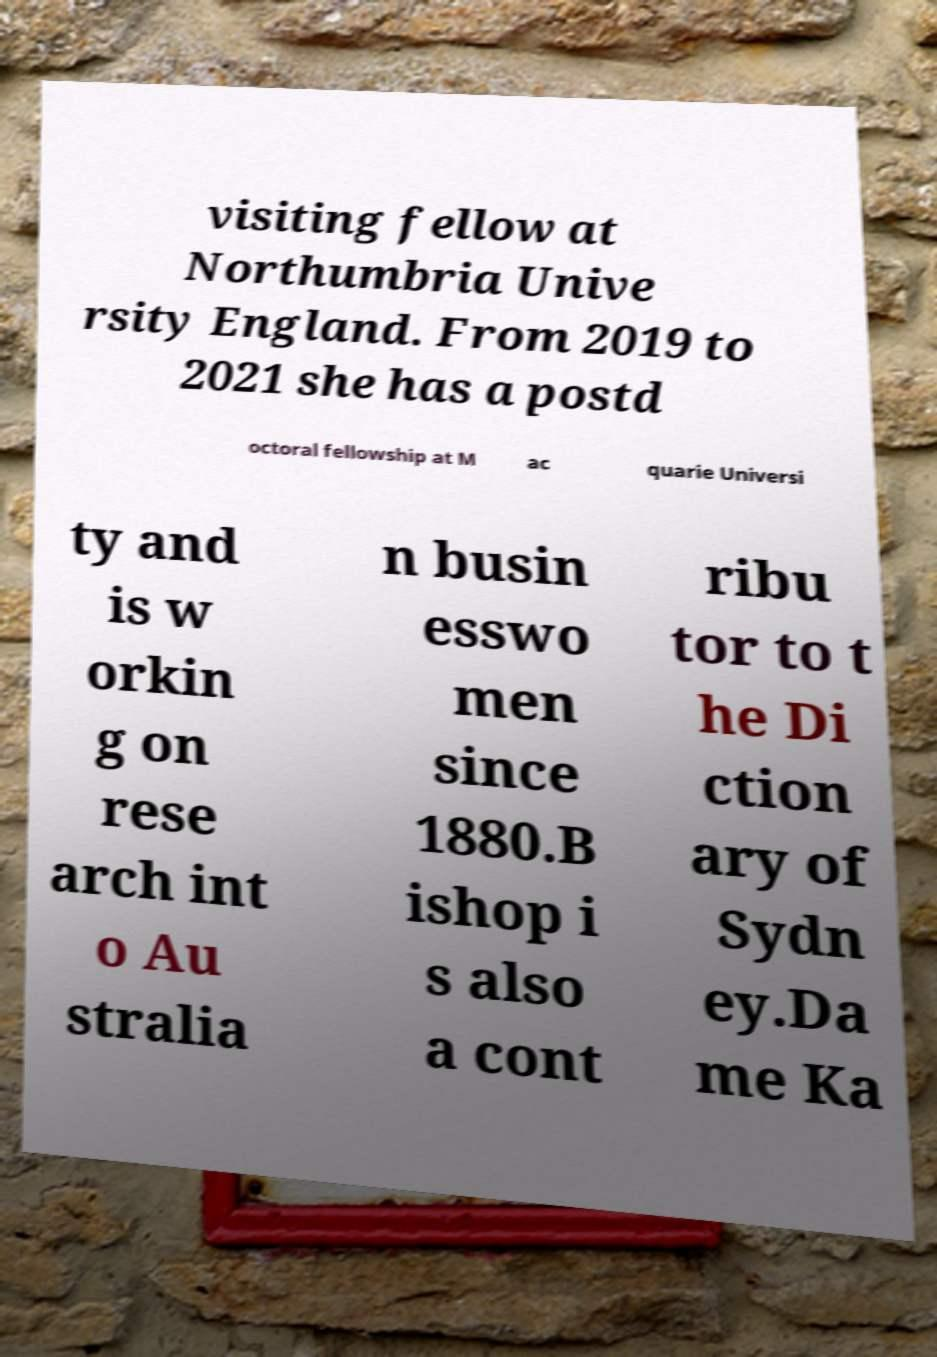Could you extract and type out the text from this image? visiting fellow at Northumbria Unive rsity England. From 2019 to 2021 she has a postd octoral fellowship at M ac quarie Universi ty and is w orkin g on rese arch int o Au stralia n busin esswo men since 1880.B ishop i s also a cont ribu tor to t he Di ction ary of Sydn ey.Da me Ka 